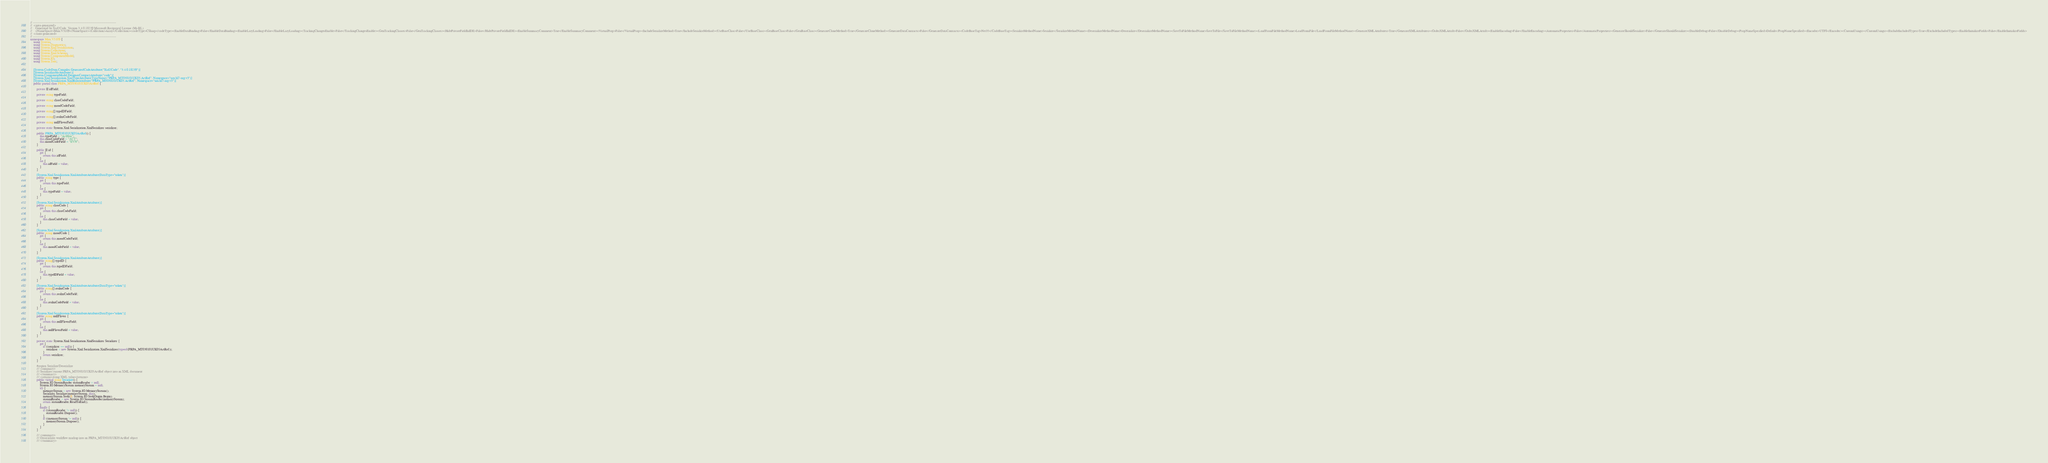<code> <loc_0><loc_0><loc_500><loc_500><_C#_>// ------------------------------------------------------------------------------
//  <auto-generated>
//    Generated by Xsd2Code. Version 3.4.0.18239 Microsoft Reciprocal License (Ms-RL) 
//    <NameSpace>Mim.V3109</NameSpace><Collection>Array</Collection><codeType>CSharp</codeType><EnableDataBinding>False</EnableDataBinding><EnableLazyLoading>False</EnableLazyLoading><TrackingChangesEnable>False</TrackingChangesEnable><GenTrackingClasses>False</GenTrackingClasses><HidePrivateFieldInIDE>False</HidePrivateFieldInIDE><EnableSummaryComment>True</EnableSummaryComment><VirtualProp>False</VirtualProp><IncludeSerializeMethod>True</IncludeSerializeMethod><UseBaseClass>False</UseBaseClass><GenBaseClass>False</GenBaseClass><GenerateCloneMethod>True</GenerateCloneMethod><GenerateDataContracts>False</GenerateDataContracts><CodeBaseTag>Net35</CodeBaseTag><SerializeMethodName>Serialize</SerializeMethodName><DeserializeMethodName>Deserialize</DeserializeMethodName><SaveToFileMethodName>SaveToFile</SaveToFileMethodName><LoadFromFileMethodName>LoadFromFile</LoadFromFileMethodName><GenerateXMLAttributes>True</GenerateXMLAttributes><OrderXMLAttrib>False</OrderXMLAttrib><EnableEncoding>False</EnableEncoding><AutomaticProperties>False</AutomaticProperties><GenerateShouldSerialize>False</GenerateShouldSerialize><DisableDebug>False</DisableDebug><PropNameSpecified>Default</PropNameSpecified><Encoder>UTF8</Encoder><CustomUsings></CustomUsings><ExcludeIncludedTypes>True</ExcludeIncludedTypes><EnableInitializeFields>False</EnableInitializeFields>
//  </auto-generated>
// ------------------------------------------------------------------------------
namespace Mim.V3109 {
    using System;
    using System.Diagnostics;
    using System.Xml.Serialization;
    using System.Collections;
    using System.Xml.Schema;
    using System.ComponentModel;
    using System.IO;
    using System.Text;
    
    
    [System.CodeDom.Compiler.GeneratedCodeAttribute("Xsd2Code", "3.4.0.18239")]
    [System.SerializableAttribute()]
    [System.ComponentModel.DesignerCategoryAttribute("code")]
    [System.Xml.Serialization.XmlTypeAttribute(TypeName="PRPA_MT030101UK05.ActRef", Namespace="urn:hl7-org:v3")]
    [System.Xml.Serialization.XmlRootAttribute("PRPA_MT030101UK05.ActRef", Namespace="urn:hl7-org:v3")]
    public partial class PRPA_MT030101UK05ActRef {
        
        private II idField;
        
        private string typeField;
        
        private string classCodeField;
        
        private string moodCodeField;
        
        private string[] typeIDField;
        
        private string[] realmCodeField;
        
        private string nullFlavorField;
        
        private static System.Xml.Serialization.XmlSerializer serializer;
        
        public PRPA_MT030101UK05ActRef() {
            this.typeField = "ActHeir";
            this.classCodeField = "ACT";
            this.moodCodeField = "EVN";
        }
        
        public II id {
            get {
                return this.idField;
            }
            set {
                this.idField = value;
            }
        }
        
        [System.Xml.Serialization.XmlAttributeAttribute(DataType="token")]
        public string type {
            get {
                return this.typeField;
            }
            set {
                this.typeField = value;
            }
        }
        
        [System.Xml.Serialization.XmlAttributeAttribute()]
        public string classCode {
            get {
                return this.classCodeField;
            }
            set {
                this.classCodeField = value;
            }
        }
        
        [System.Xml.Serialization.XmlAttributeAttribute()]
        public string moodCode {
            get {
                return this.moodCodeField;
            }
            set {
                this.moodCodeField = value;
            }
        }
        
        [System.Xml.Serialization.XmlAttributeAttribute()]
        public string[] typeID {
            get {
                return this.typeIDField;
            }
            set {
                this.typeIDField = value;
            }
        }
        
        [System.Xml.Serialization.XmlAttributeAttribute(DataType="token")]
        public string[] realmCode {
            get {
                return this.realmCodeField;
            }
            set {
                this.realmCodeField = value;
            }
        }
        
        [System.Xml.Serialization.XmlAttributeAttribute(DataType="token")]
        public string nullFlavor {
            get {
                return this.nullFlavorField;
            }
            set {
                this.nullFlavorField = value;
            }
        }
        
        private static System.Xml.Serialization.XmlSerializer Serializer {
            get {
                if ((serializer == null)) {
                    serializer = new System.Xml.Serialization.XmlSerializer(typeof(PRPA_MT030101UK05ActRef));
                }
                return serializer;
            }
        }
        
        #region Serialize/Deserialize
        /// <summary>
        /// Serializes current PRPA_MT030101UK05ActRef object into an XML document
        /// </summary>
        /// <returns>string XML value</returns>
        public virtual string Serialize() {
            System.IO.StreamReader streamReader = null;
            System.IO.MemoryStream memoryStream = null;
            try {
                memoryStream = new System.IO.MemoryStream();
                Serializer.Serialize(memoryStream, this);
                memoryStream.Seek(0, System.IO.SeekOrigin.Begin);
                streamReader = new System.IO.StreamReader(memoryStream);
                return streamReader.ReadToEnd();
            }
            finally {
                if ((streamReader != null)) {
                    streamReader.Dispose();
                }
                if ((memoryStream != null)) {
                    memoryStream.Dispose();
                }
            }
        }
        
        /// <summary>
        /// Deserializes workflow markup into an PRPA_MT030101UK05ActRef object
        /// </summary></code> 